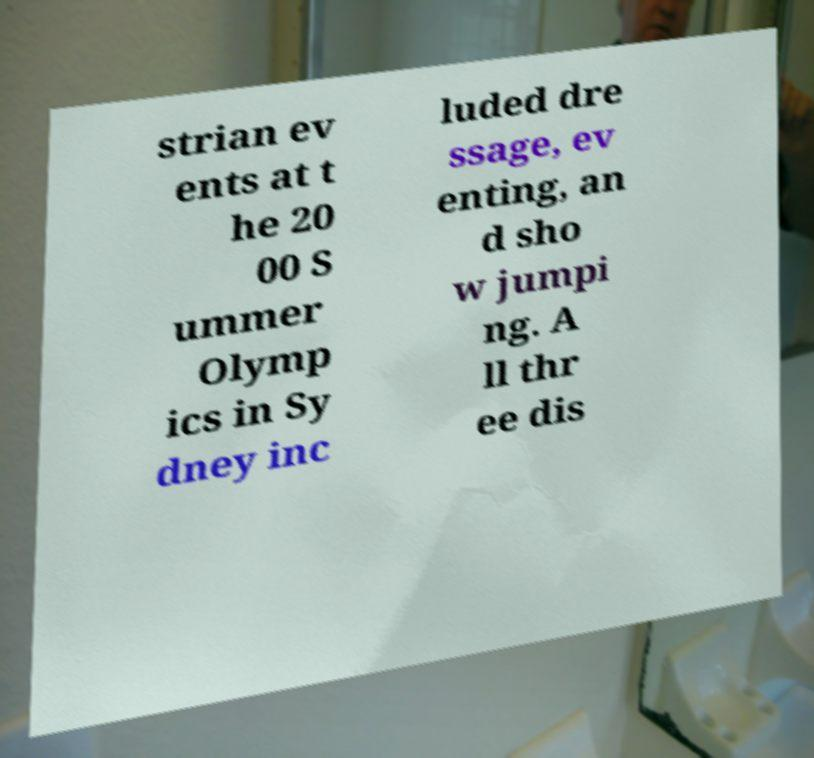Can you read and provide the text displayed in the image?This photo seems to have some interesting text. Can you extract and type it out for me? strian ev ents at t he 20 00 S ummer Olymp ics in Sy dney inc luded dre ssage, ev enting, an d sho w jumpi ng. A ll thr ee dis 